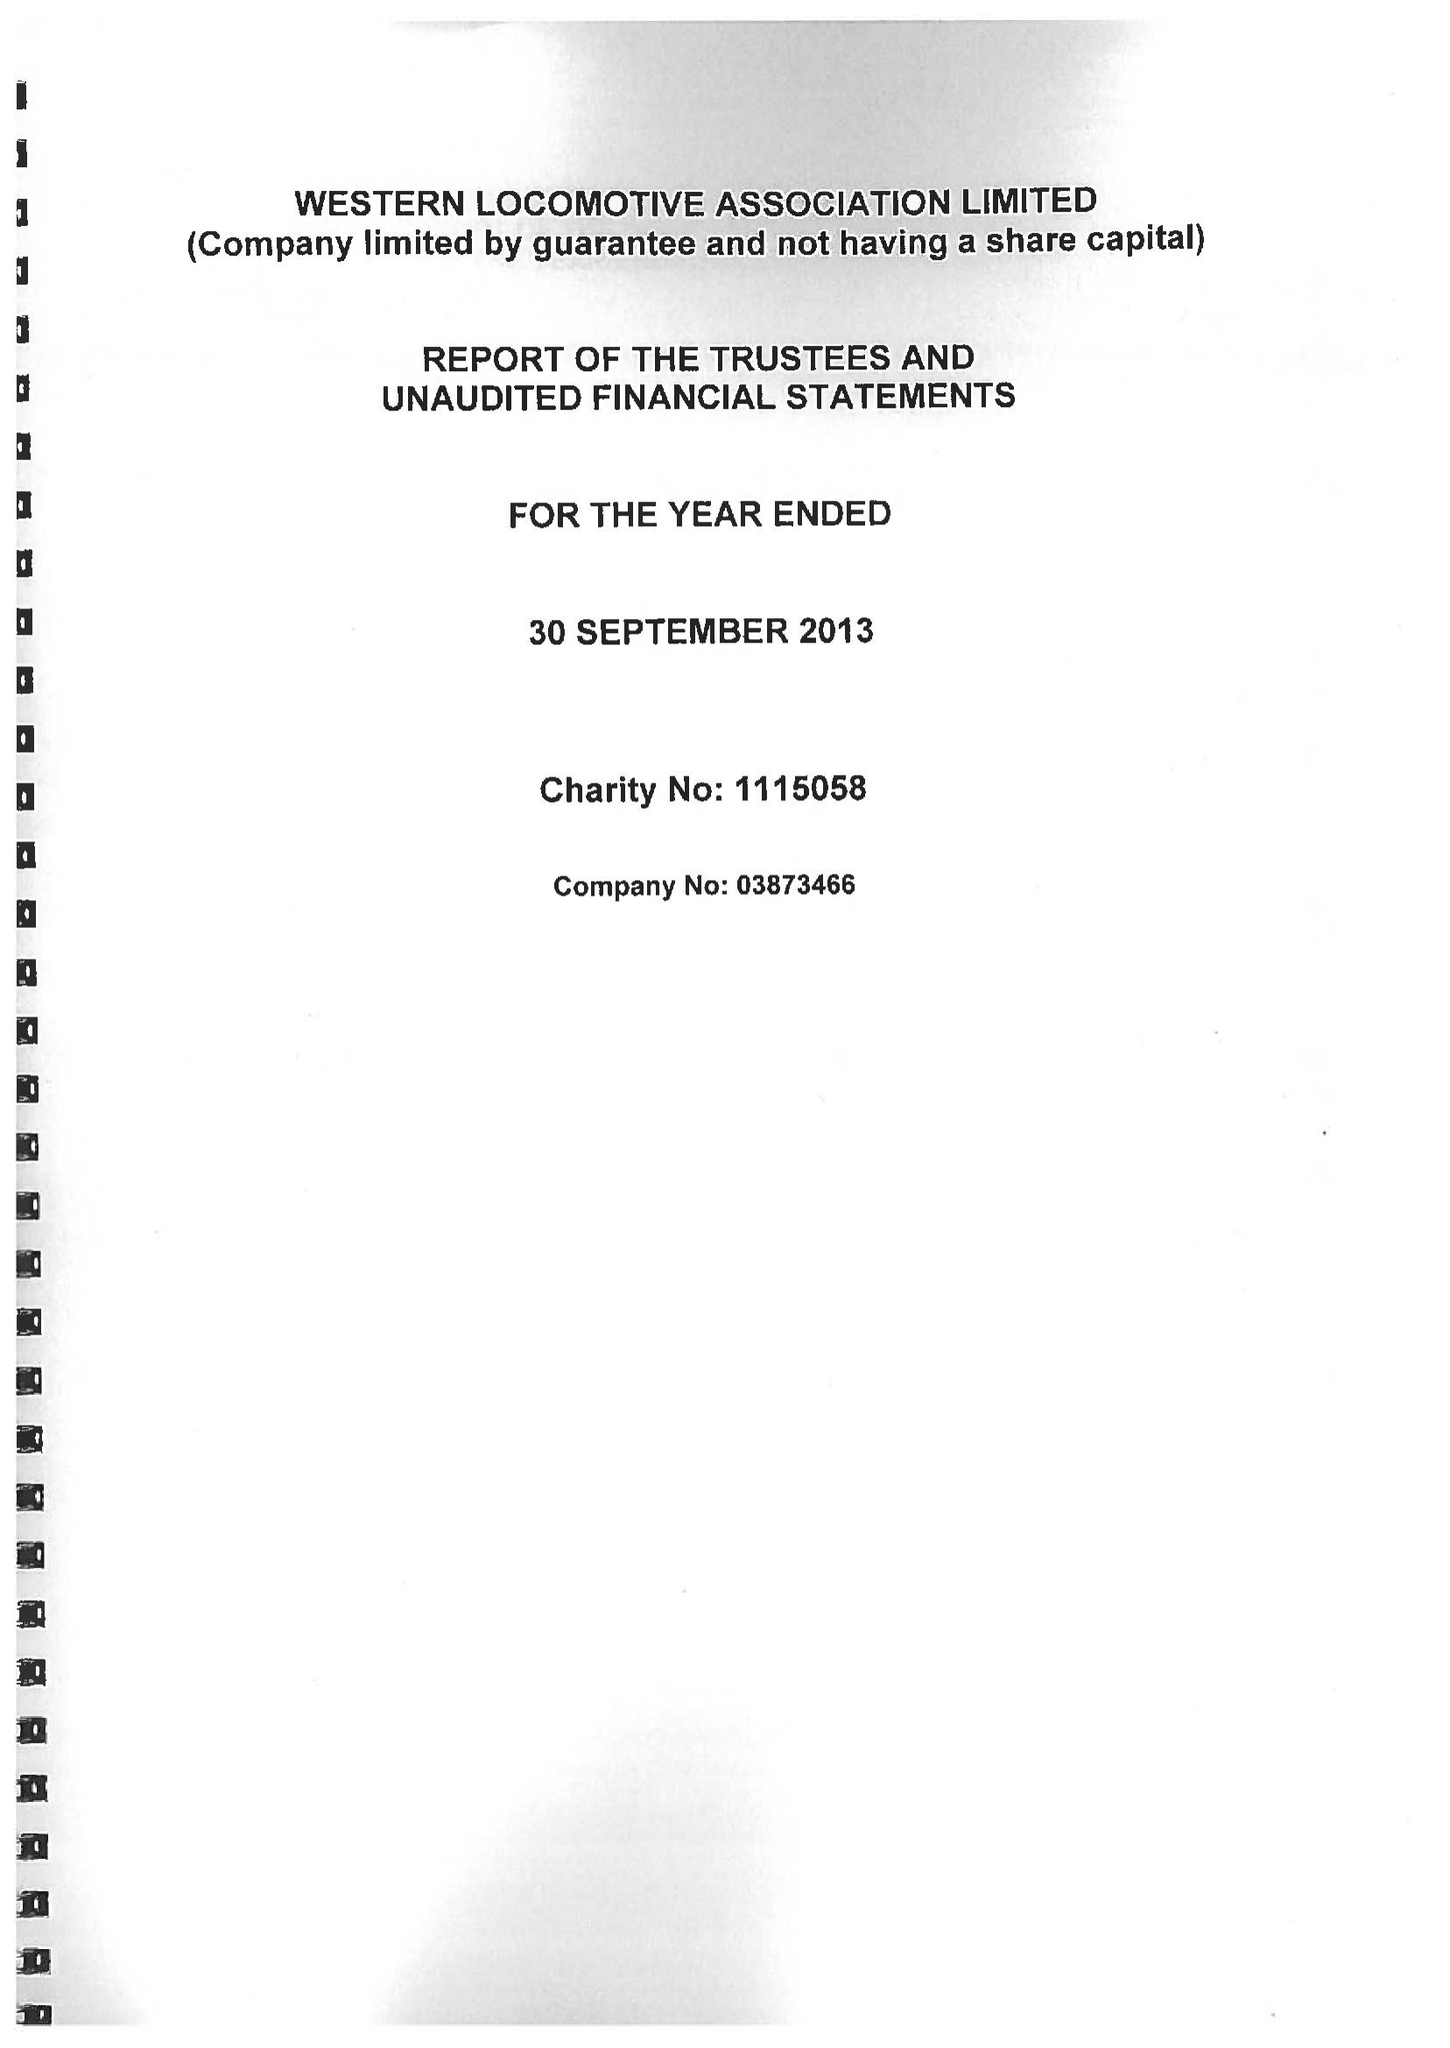What is the value for the address__post_town?
Answer the question using a single word or phrase. STAFFORD 